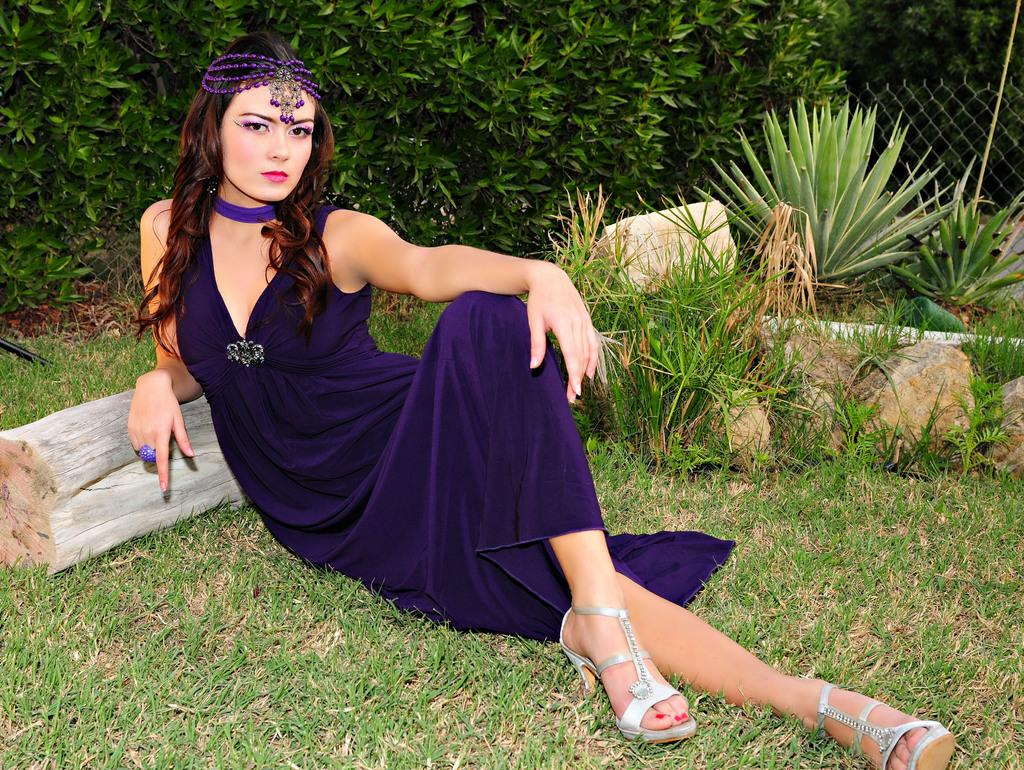What is the woman in the image doing? The woman is sitting on the grass in the image. What can be seen behind the woman? There is a wooden object behind the woman. What type of natural elements are present in the image? There are stones and plants visible in the image. What type of structure can be seen in the image? There is a fence in the image. What color is predominant in the background of the image? Green leaves are visible in the background. What type of trade is being conducted in the image? There is no indication of trade in the image. 